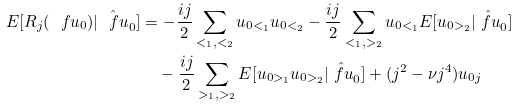<formula> <loc_0><loc_0><loc_500><loc_500>E [ R _ { j } ( { \ f u _ { 0 } } ) | \hat { \ f u } _ { 0 } ] & = - \frac { i j } { 2 } \sum _ { < _ { 1 } , < _ { 2 } } u _ { 0 < _ { 1 } } u _ { 0 < _ { 2 } } - \frac { i j } { 2 } \sum _ { < _ { 1 } , > _ { 2 } } u _ { 0 < _ { 1 } } E [ u _ { 0 > _ { 2 } } | \hat { \ f u } _ { 0 } ] \\ & \quad - \frac { i j } { 2 } \sum _ { > _ { 1 } , > _ { 2 } } E [ u _ { 0 > _ { 1 } } u _ { 0 > _ { 2 } } | \hat { \ f u } _ { 0 } ] + ( j ^ { 2 } - \nu j ^ { 4 } ) u _ { 0 j }</formula> 